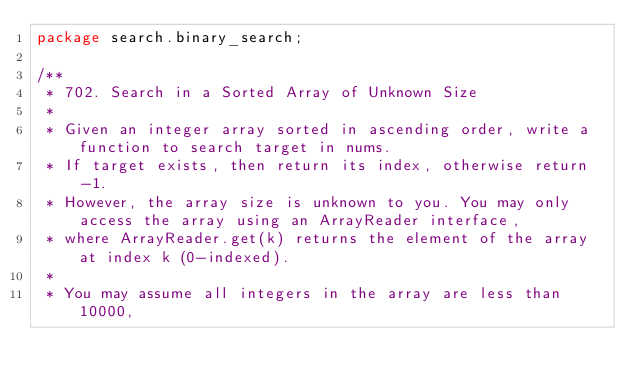<code> <loc_0><loc_0><loc_500><loc_500><_Java_>package search.binary_search;

/**
 * 702. Search in a Sorted Array of Unknown Size
 *
 * Given an integer array sorted in ascending order, write a function to search target in nums.
 * If target exists, then return its index, otherwise return -1.
 * However, the array size is unknown to you. You may only access the array using an ArrayReader interface,
 * where ArrayReader.get(k) returns the element of the array at index k (0-indexed).
 *
 * You may assume all integers in the array are less than 10000,</code> 